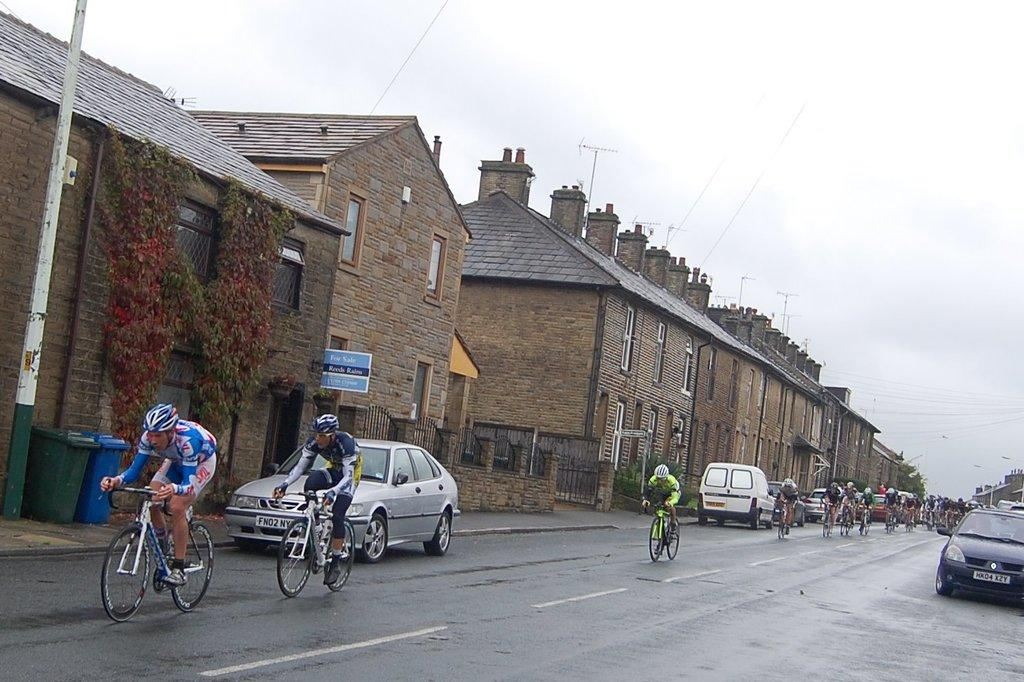What are the people in the foreground of the image doing? The people in the foreground of the image are cycling. What else can be seen in the foreground of the image? There are vehicles and trash bins in the foreground of the image. What is visible in the background of the image? There are houses, poles, and the sky visible in the background of the image. Can you see any fish swimming in the image? There are no fish visible in the image. What type of industry is depicted in the image? The image does not depict any industry; it features people cycling, vehicles, trash bins, houses, poles, and the sky. 